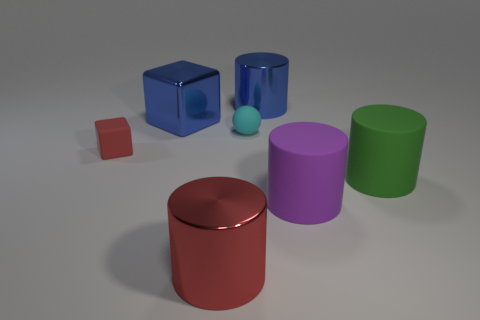Subtract all blue cylinders. How many cylinders are left? 3 Subtract 1 cylinders. How many cylinders are left? 3 Subtract all yellow cylinders. Subtract all yellow balls. How many cylinders are left? 4 Add 2 yellow balls. How many objects exist? 9 Subtract all cylinders. How many objects are left? 3 Subtract all cyan rubber spheres. Subtract all blue shiny cylinders. How many objects are left? 5 Add 1 matte balls. How many matte balls are left? 2 Add 5 metal cylinders. How many metal cylinders exist? 7 Subtract 0 brown blocks. How many objects are left? 7 